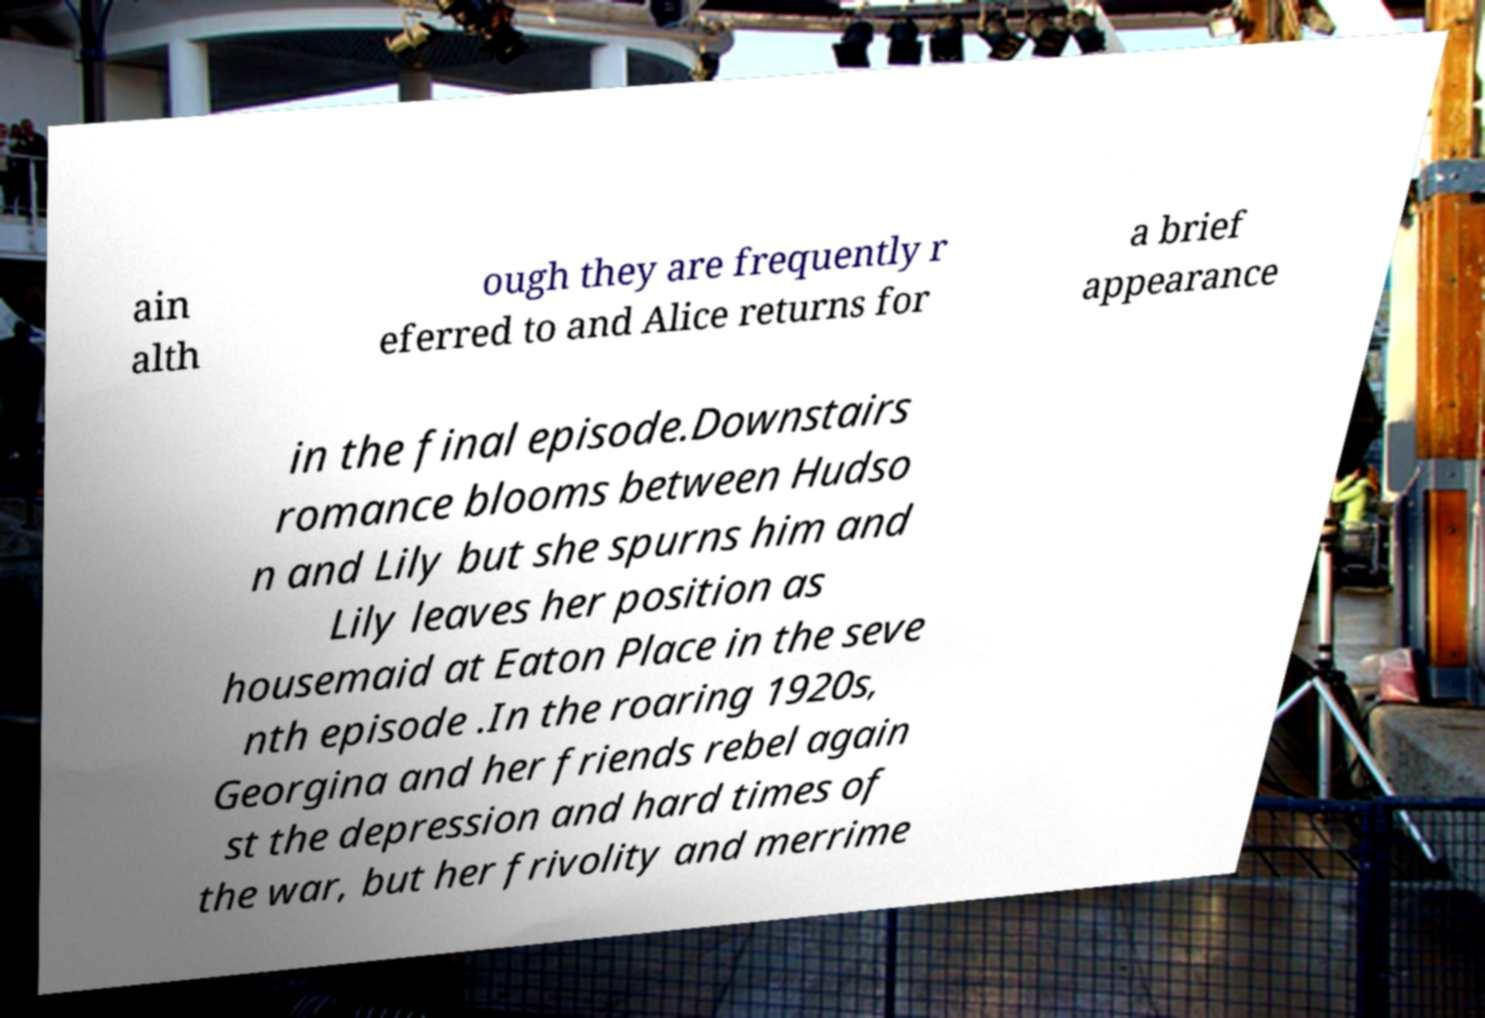There's text embedded in this image that I need extracted. Can you transcribe it verbatim? ain alth ough they are frequently r eferred to and Alice returns for a brief appearance in the final episode.Downstairs romance blooms between Hudso n and Lily but she spurns him and Lily leaves her position as housemaid at Eaton Place in the seve nth episode .In the roaring 1920s, Georgina and her friends rebel again st the depression and hard times of the war, but her frivolity and merrime 